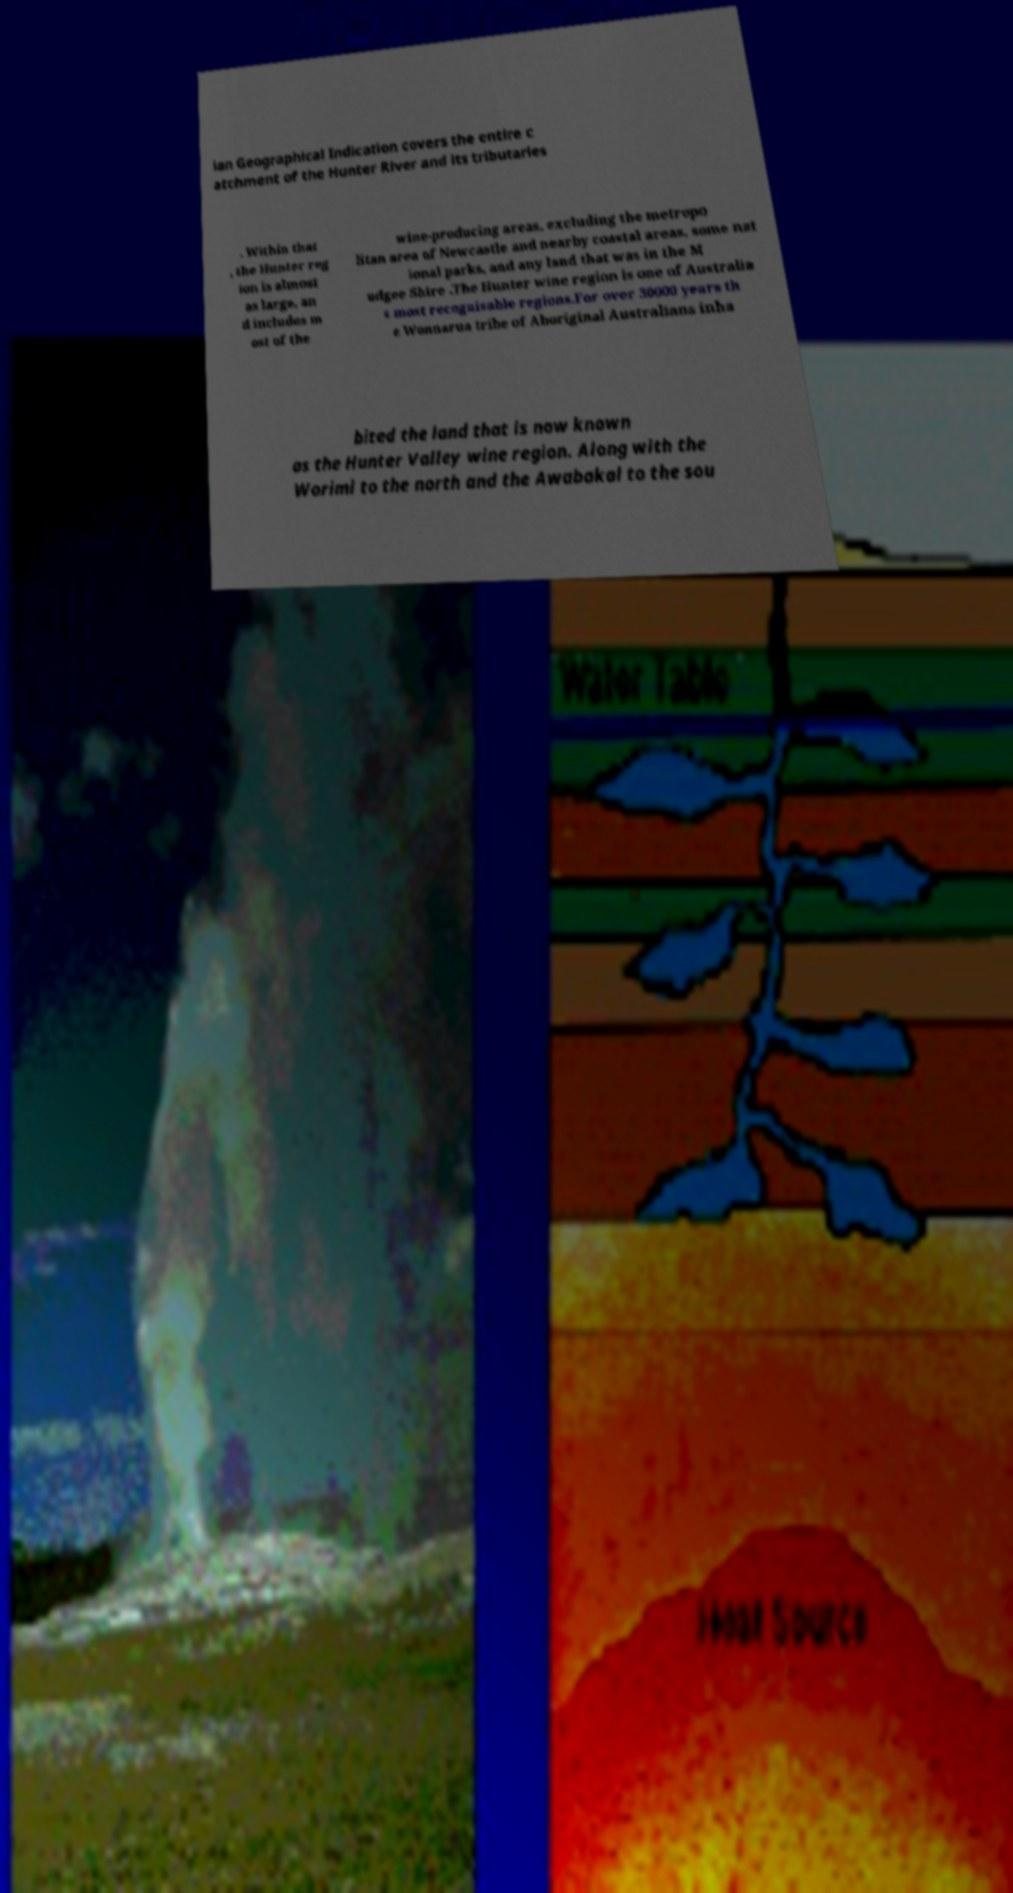Please identify and transcribe the text found in this image. ian Geographical Indication covers the entire c atchment of the Hunter River and its tributaries . Within that , the Hunter reg ion is almost as large, an d includes m ost of the wine-producing areas, excluding the metropo litan area of Newcastle and nearby coastal areas, some nat ional parks, and any land that was in the M udgee Shire .The Hunter wine region is one of Australia s most recognisable regions.For over 30000 years th e Wonnarua tribe of Aboriginal Australians inha bited the land that is now known as the Hunter Valley wine region. Along with the Worimi to the north and the Awabakal to the sou 